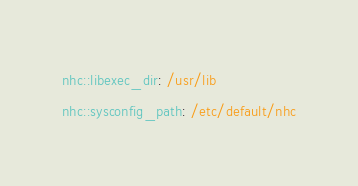Convert code to text. <code><loc_0><loc_0><loc_500><loc_500><_YAML_>nhc::libexec_dir: /usr/lib
nhc::sysconfig_path: /etc/default/nhc
</code> 